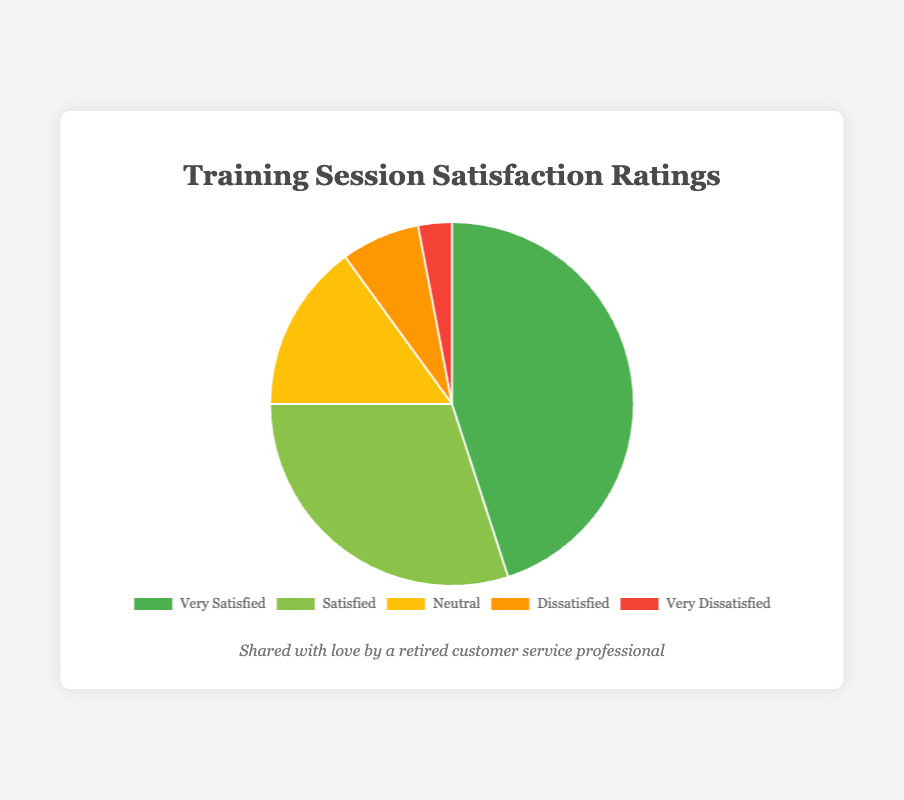Which satisfaction category has the highest number of responses? The "Very Satisfied" category has the highest number of responses, which is visually shown by the largest segment of the pie chart.
Answer: Very Satisfied What is the combined percentage of Neutral and Dissatisfied responses? The Neutral responses are 15% and the Dissatisfied responses are 7%. Adding these together: 15% + 7% = 22%.
Answer: 22% Is the number of Satisfied responses greater than Neutral responses? The pie chart shows Satisfied responses at 30%, which is greater than 15% for Neutral responses.
Answer: Yes Which satisfaction category is represented by the smallest segment, and what is its percentage? The smallest segment is the "Very Dissatisfied" category, represented by 3%.
Answer: Very Dissatisfied, 3% What is the difference in percentage between Very Satisfied and Dissatisfied responses? The Very Satisfied responses are at 45% and the Dissatisfied responses are at 7%. The difference is 45% - 7% = 38%.
Answer: 38% How do the combined percentages of Very Satisfied and Satisfied compare to the total percentage of Neutral, Dissatisfied, and Very Dissatisfied? The combined percentage of Very Satisfied and Satisfied is 45% + 30% = 75%. The total of Neutral, Dissatisfied, and Very Dissatisfied is 15% + 7% + 3% = 25%. Therefore, 75% is greater than 25%.
Answer: 75% vs 25% What color represents the Neutral category in the pie chart? The Neutral category is represented by the yellow segment.
Answer: Yellow If 100 people were surveyed, how many reported being Very Dissatisfied? If 3% of respondents are Very Dissatisfied out of 100 people, then 3% of 100 equals 3 people.
Answer: 3 How many more people were Very Satisfied compared to Neutral? The pie chart shows 45% for Very Satisfied and 15% for Neutral. The difference percentage is 45% - 15% = 30%. Out of 100 people, 30 more people were Very Satisfied compared to Neutral.
Answer: 30 